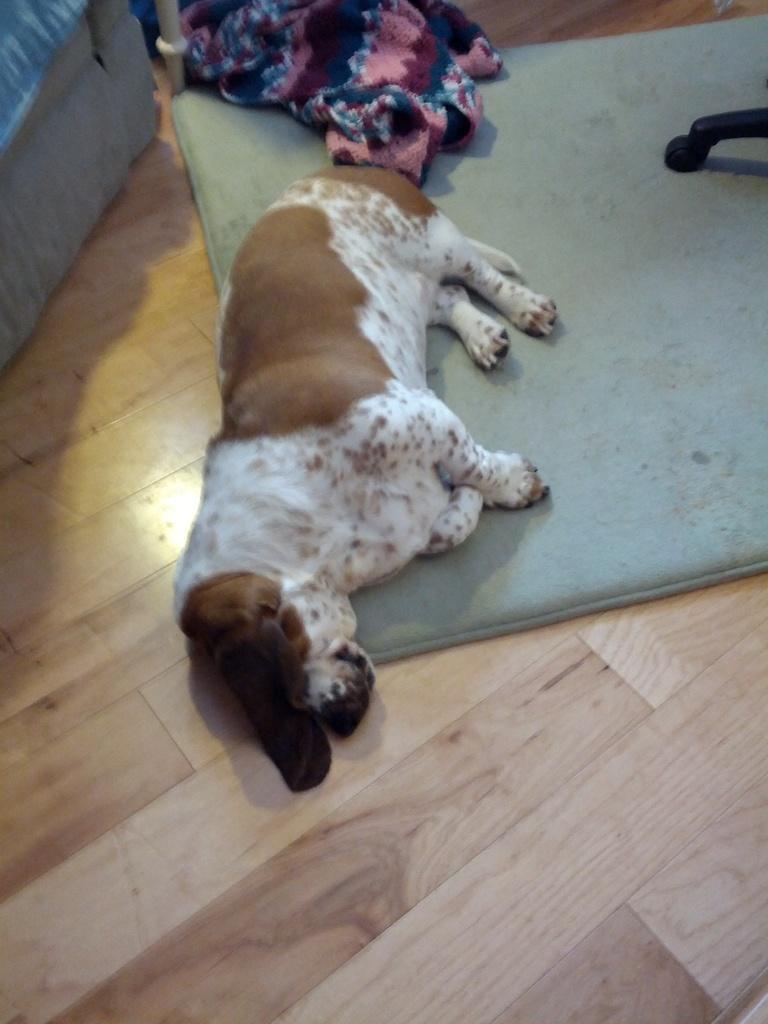Can you describe this image briefly? In the image there is a dog laying on carpet on a wooden floor, on the left side corner it seems to be a wooden sofa and on right side it seems to be a wheel chair. 